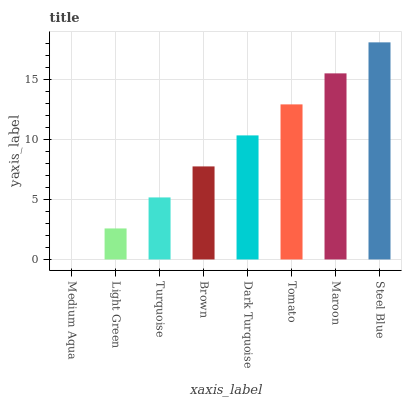Is Light Green the minimum?
Answer yes or no. No. Is Light Green the maximum?
Answer yes or no. No. Is Light Green greater than Medium Aqua?
Answer yes or no. Yes. Is Medium Aqua less than Light Green?
Answer yes or no. Yes. Is Medium Aqua greater than Light Green?
Answer yes or no. No. Is Light Green less than Medium Aqua?
Answer yes or no. No. Is Dark Turquoise the high median?
Answer yes or no. Yes. Is Brown the low median?
Answer yes or no. Yes. Is Brown the high median?
Answer yes or no. No. Is Turquoise the low median?
Answer yes or no. No. 